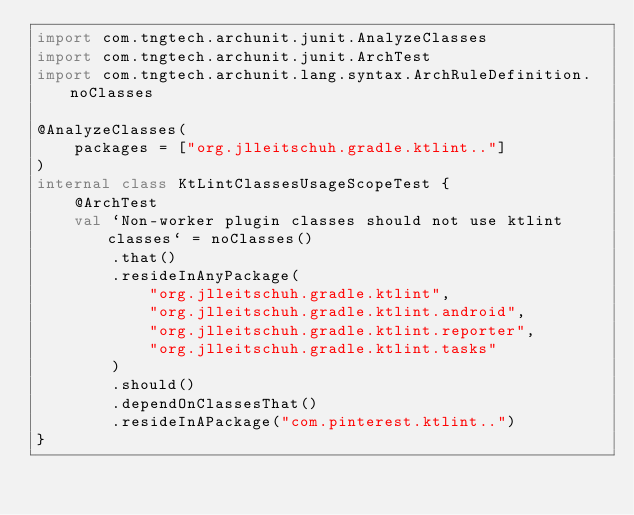Convert code to text. <code><loc_0><loc_0><loc_500><loc_500><_Kotlin_>import com.tngtech.archunit.junit.AnalyzeClasses
import com.tngtech.archunit.junit.ArchTest
import com.tngtech.archunit.lang.syntax.ArchRuleDefinition.noClasses

@AnalyzeClasses(
    packages = ["org.jlleitschuh.gradle.ktlint.."]
)
internal class KtLintClassesUsageScopeTest {
    @ArchTest
    val `Non-worker plugin classes should not use ktlint classes` = noClasses()
        .that()
        .resideInAnyPackage(
            "org.jlleitschuh.gradle.ktlint",
            "org.jlleitschuh.gradle.ktlint.android",
            "org.jlleitschuh.gradle.ktlint.reporter",
            "org.jlleitschuh.gradle.ktlint.tasks"
        )
        .should()
        .dependOnClassesThat()
        .resideInAPackage("com.pinterest.ktlint..")
}
</code> 